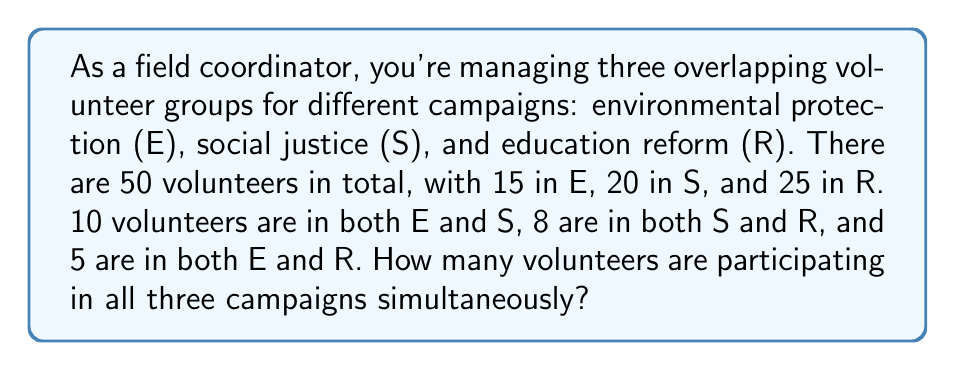Can you answer this question? To solve this problem, we'll use set theory and the principle of inclusion-exclusion. Let's break it down step-by-step:

1. Define the sets:
   $E$: Environmental protection volunteers
   $S$: Social justice volunteers
   $R$: Education reform volunteers

2. Given information:
   $|E| = 15$, $|S| = 20$, $|R| = 25$
   $|E \cap S| = 10$, $|S \cap R| = 8$, $|E \cap R| = 5$
   Total volunteers: $|E \cup S \cup R| = 50$

3. Use the inclusion-exclusion principle:
   $$|E \cup S \cup R| = |E| + |S| + |R| - |E \cap S| - |S \cap R| - |E \cap R| + |E \cap S \cap R|$$

4. Substitute the known values:
   $$50 = 15 + 20 + 25 - 10 - 8 - 5 + |E \cap S \cap R|$$

5. Solve for $|E \cap S \cap R|$:
   $$|E \cap S \cap R| = 50 - (15 + 20 + 25 - 10 - 8 - 5)$$
   $$|E \cap S \cap R| = 50 - 37 = 13$$

Therefore, 13 volunteers are participating in all three campaigns simultaneously.
Answer: 13 volunteers 